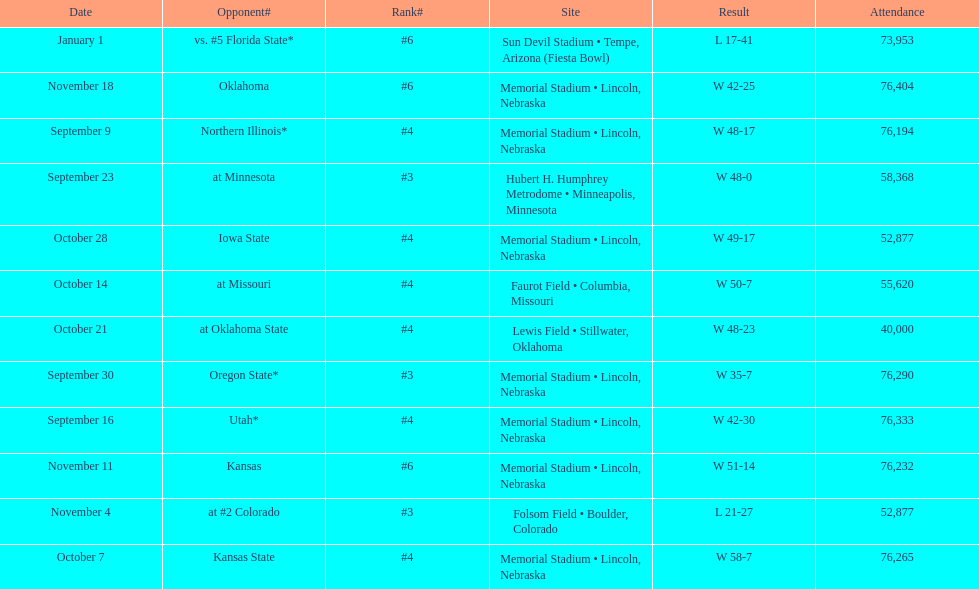What is the next site listed after lewis field? Memorial Stadium • Lincoln, Nebraska. 